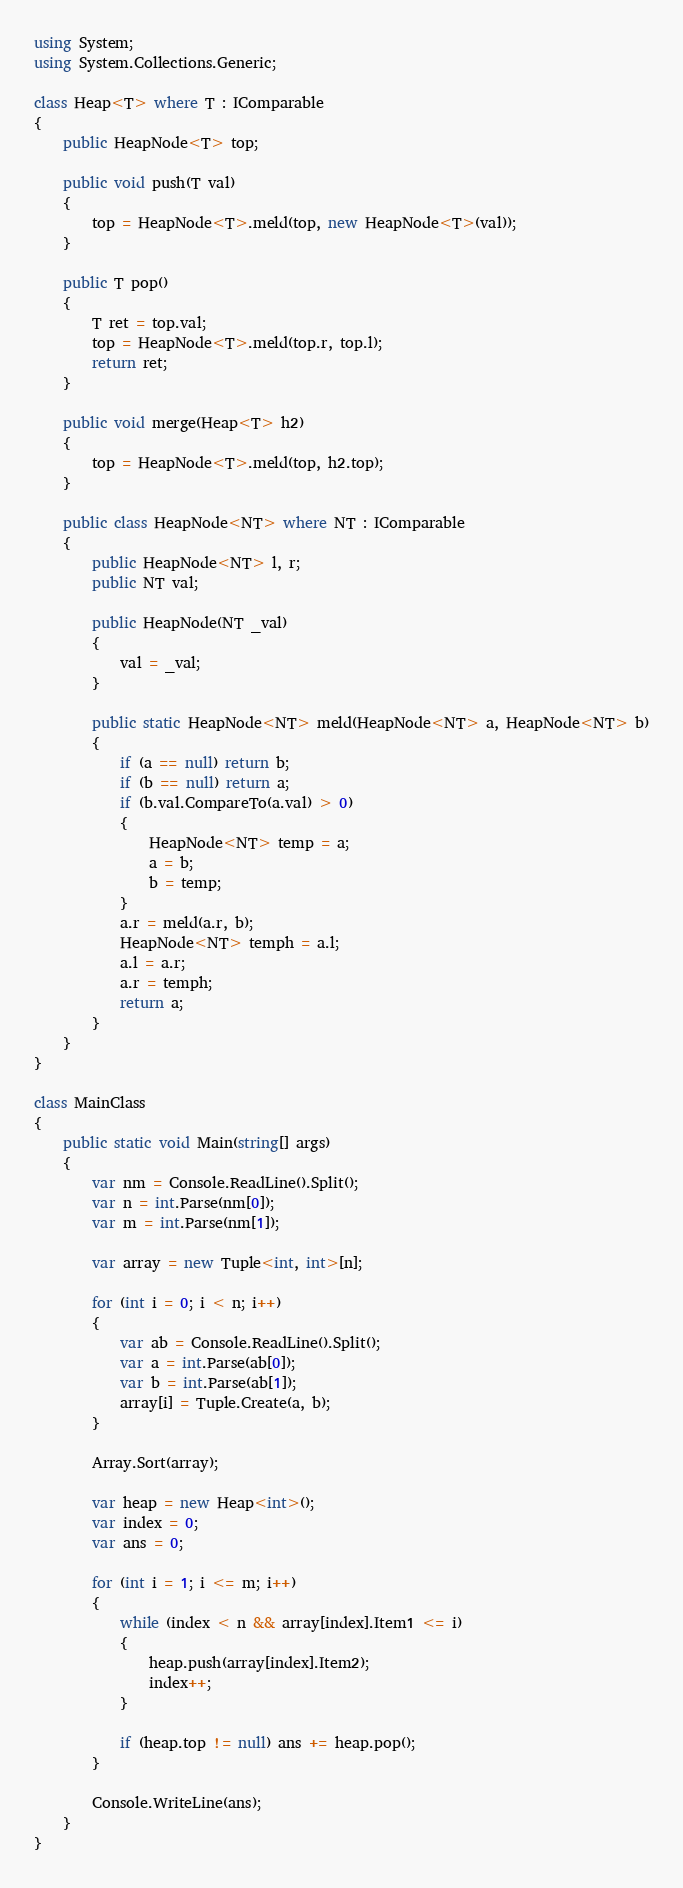Convert code to text. <code><loc_0><loc_0><loc_500><loc_500><_C#_>using System;
using System.Collections.Generic;

class Heap<T> where T : IComparable
{
    public HeapNode<T> top;

    public void push(T val)
    {
        top = HeapNode<T>.meld(top, new HeapNode<T>(val));
    }

    public T pop()
    {
        T ret = top.val;
        top = HeapNode<T>.meld(top.r, top.l);
        return ret;
    }

    public void merge(Heap<T> h2)
    {
        top = HeapNode<T>.meld(top, h2.top);
    }

    public class HeapNode<NT> where NT : IComparable
    {
        public HeapNode<NT> l, r;
        public NT val;

        public HeapNode(NT _val)
        {
            val = _val;
        }

        public static HeapNode<NT> meld(HeapNode<NT> a, HeapNode<NT> b)
        {
            if (a == null) return b;
            if (b == null) return a;
            if (b.val.CompareTo(a.val) > 0)
            {
                HeapNode<NT> temp = a;
                a = b;
                b = temp;
            }
            a.r = meld(a.r, b);
            HeapNode<NT> temph = a.l;
            a.l = a.r;
            a.r = temph;
            return a;
        }
    }
}

class MainClass
{
    public static void Main(string[] args)
    {
        var nm = Console.ReadLine().Split();
        var n = int.Parse(nm[0]);
        var m = int.Parse(nm[1]);

        var array = new Tuple<int, int>[n];

        for (int i = 0; i < n; i++)
        {
            var ab = Console.ReadLine().Split();
            var a = int.Parse(ab[0]);
            var b = int.Parse(ab[1]);
            array[i] = Tuple.Create(a, b);
        }

        Array.Sort(array);

        var heap = new Heap<int>();
        var index = 0;
        var ans = 0;

        for (int i = 1; i <= m; i++)
        {
            while (index < n && array[index].Item1 <= i)
            {
                heap.push(array[index].Item2);
                index++;
            }

            if (heap.top != null) ans += heap.pop();
        }

        Console.WriteLine(ans);
    }
}</code> 